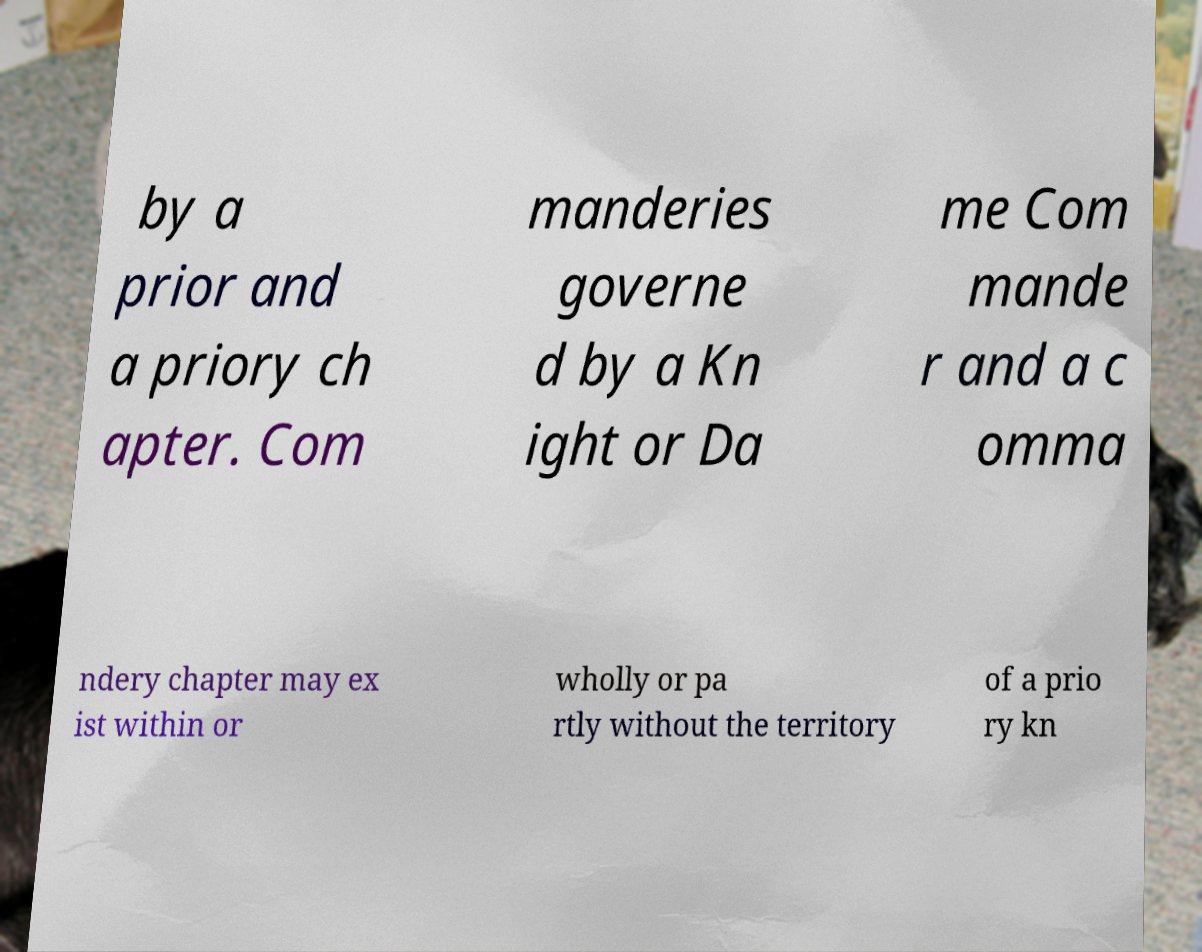Please read and relay the text visible in this image. What does it say? by a prior and a priory ch apter. Com manderies governe d by a Kn ight or Da me Com mande r and a c omma ndery chapter may ex ist within or wholly or pa rtly without the territory of a prio ry kn 